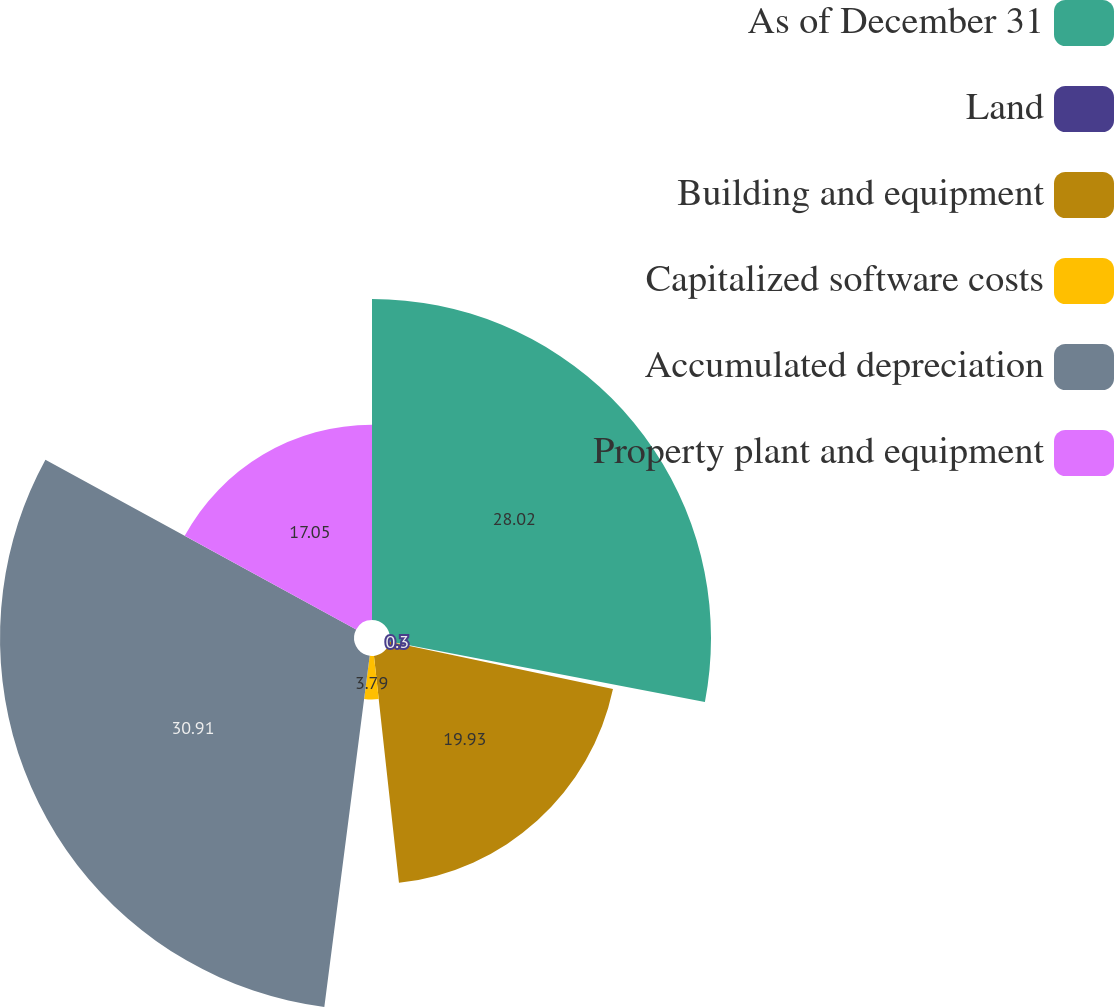Convert chart. <chart><loc_0><loc_0><loc_500><loc_500><pie_chart><fcel>As of December 31<fcel>Land<fcel>Building and equipment<fcel>Capitalized software costs<fcel>Accumulated depreciation<fcel>Property plant and equipment<nl><fcel>28.02%<fcel>0.3%<fcel>19.93%<fcel>3.79%<fcel>30.9%<fcel>17.05%<nl></chart> 